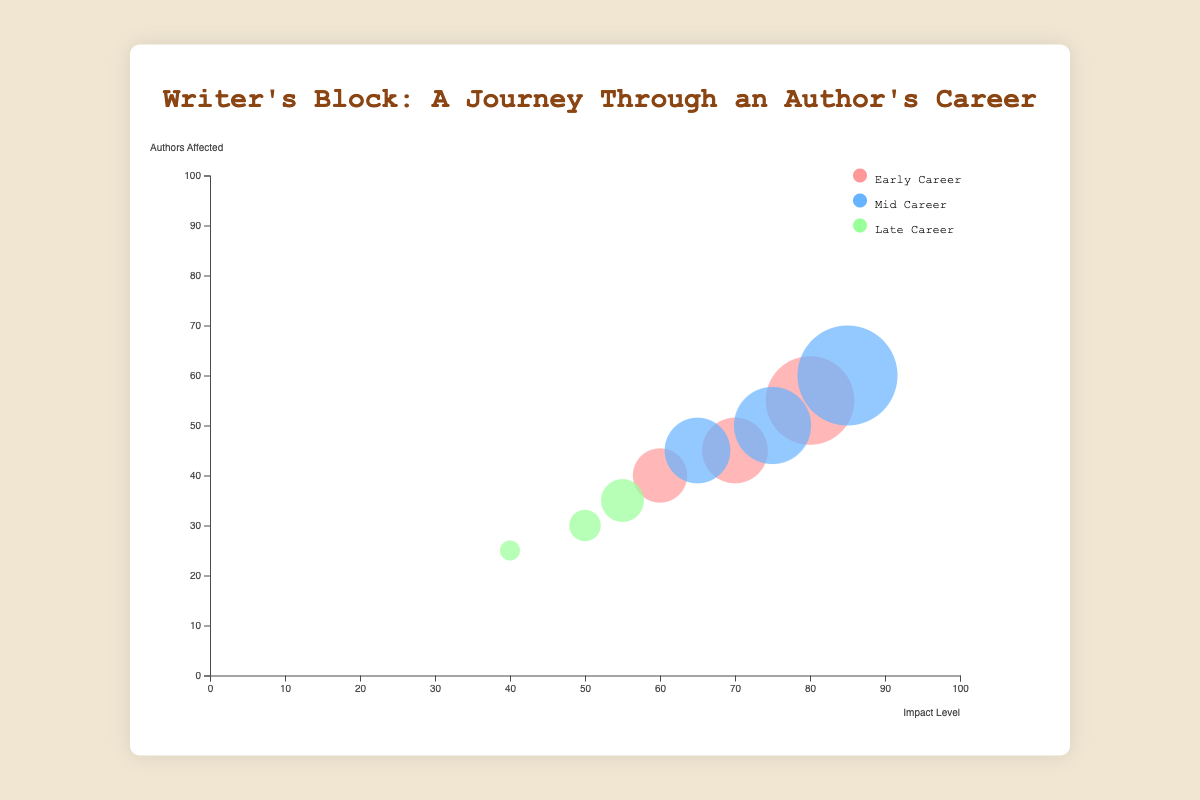What is the title of the figure? The title is usually the largest and most prominently placed text at the top of the figure. In this case, it's "Writer's Block: A Journey Through an Author's Career".
Answer: Writer's Block: A Journey Through an Author's Career How many stages in their careers are analyzed in the figure? The figure's legend and different bubble colors indicate the number of career stages being analyzed. There are three distinct stages: Early Career, Mid Career, and Late Career.
Answer: 3 Which trigger has the highest impact level in the Early Career stage? To find this, look at the x-axis values for bubbles in the Early Career category. The highest impact level for Early Career is observed in the bubble labeled "Lack of Confidence", which is at 80.
Answer: Lack of Confidence How many authors affected are associated with "Creative Burnout" in the Mid Career stage? Find the bubble labeled "Creative Burnout" under the Mid Career category. Check the y-axis position of this bubble to find the number of authors affected, which is 50.
Answer: 50 Which career stage has the most authors affected by the most impactful trigger? First, identify the highest impact level overall, which is for "Pressure to Succeed" in Mid Career with an impact level of 85. Then find the stage associated with this trigger, which is Mid Career.
Answer: Mid Career Which stage has the smallest bubble size related to "Loss of Initial Passion"? The bubble labeled "Loss of Initial Passion" falls under the Late Career stage. The size of this bubble corresponds with fewer authors affected, which is 25, making it the smallest bubble size.
Answer: Late Career Compare the impact levels between "Relevance Anxiety" and "Loss of Initial Passion" in the Late Career stage. Which is higher? Locate the bubbles for "Relevance Anxiety" and "Loss of Initial Passion" both in Late Career. Compare their x-axis values: "Relevance Anxiety" has 55, and "Loss of Initial Passion" has 40. Thus, "Relevance Anxiety" is higher.
Answer: Relevance Anxiety Which trigger affects more authors: "Personal Life Distractions" in Mid Career or "Fear of Criticism" in Early Career? Check the y-axis values for the respective bubbles. "Personal Life Distractions" affects 45 authors in Mid Career, while "Fear of Criticism" affects 45 authors in Early Career. Both have the same number of affected authors.
Answer: Same number (45 each) What is the difference in the number of authors affected between "Time Management Issues" in Early Career and "Creative Burnout" in Mid Career? Look at the y-axis values for both triggers. "Time Management Issues" affects 40 authors, and "Creative Burnout" affects 50 authors. The difference is 50 - 40 = 10 authors.
Answer: 10 authors 